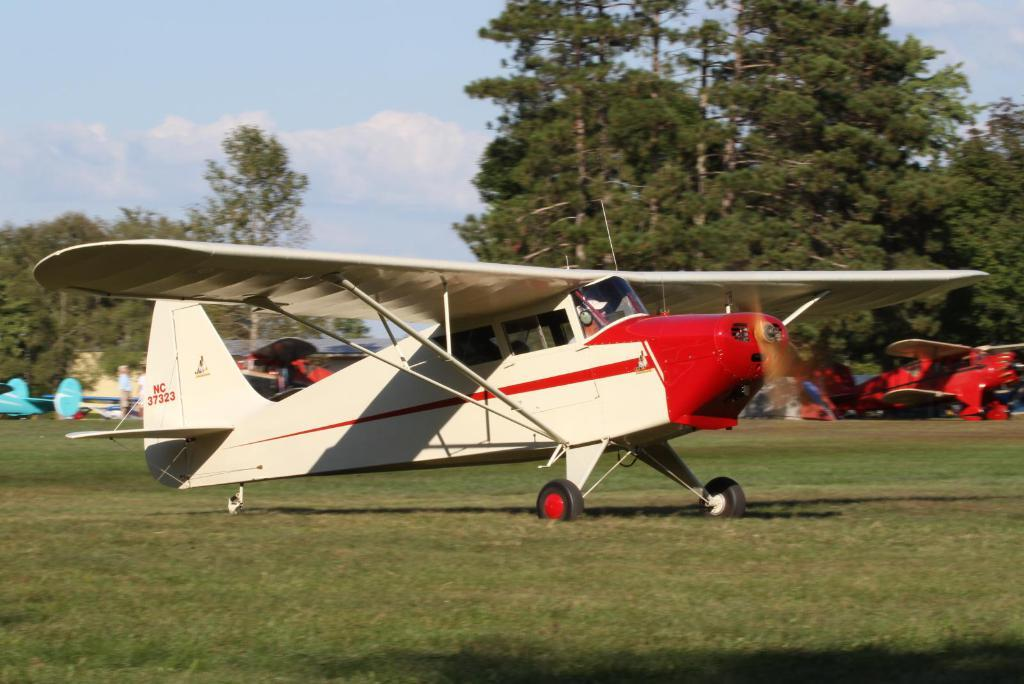What is the main subject of the image? The main subject of the image is an aircraft on the grass. How many people are in the image? There are two people in the image. What type of natural vegetation is present in the image? There are trees in the image. What can be seen in the background of the image? The sky with clouds is visible in the background of the image. What type of plough is being used to cultivate the grass in the image? There is no plough present in the image, and the grass is not being cultivated. What economic theory is being discussed by the two people in the image? There is no indication of a discussion or any specific theory in the image. 